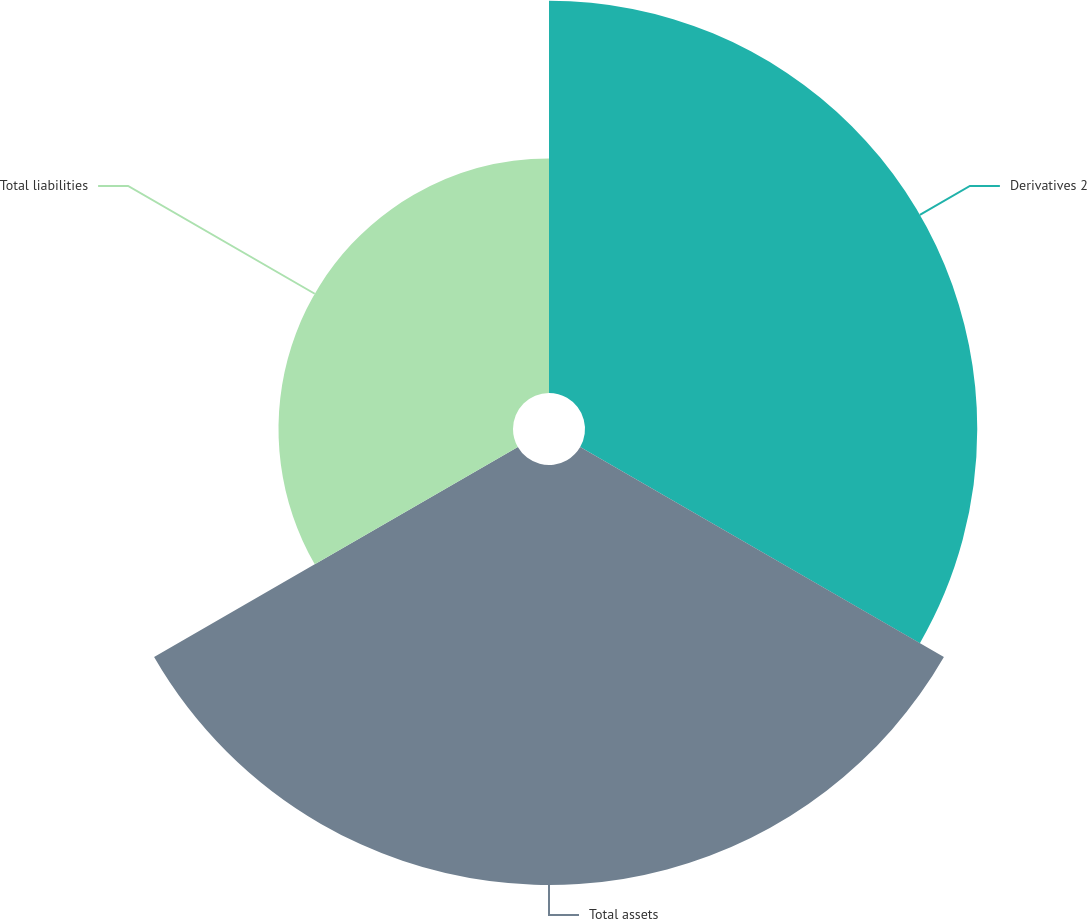Convert chart. <chart><loc_0><loc_0><loc_500><loc_500><pie_chart><fcel>Derivatives 2<fcel>Total assets<fcel>Total liabilities<nl><fcel>37.47%<fcel>40.12%<fcel>22.4%<nl></chart> 